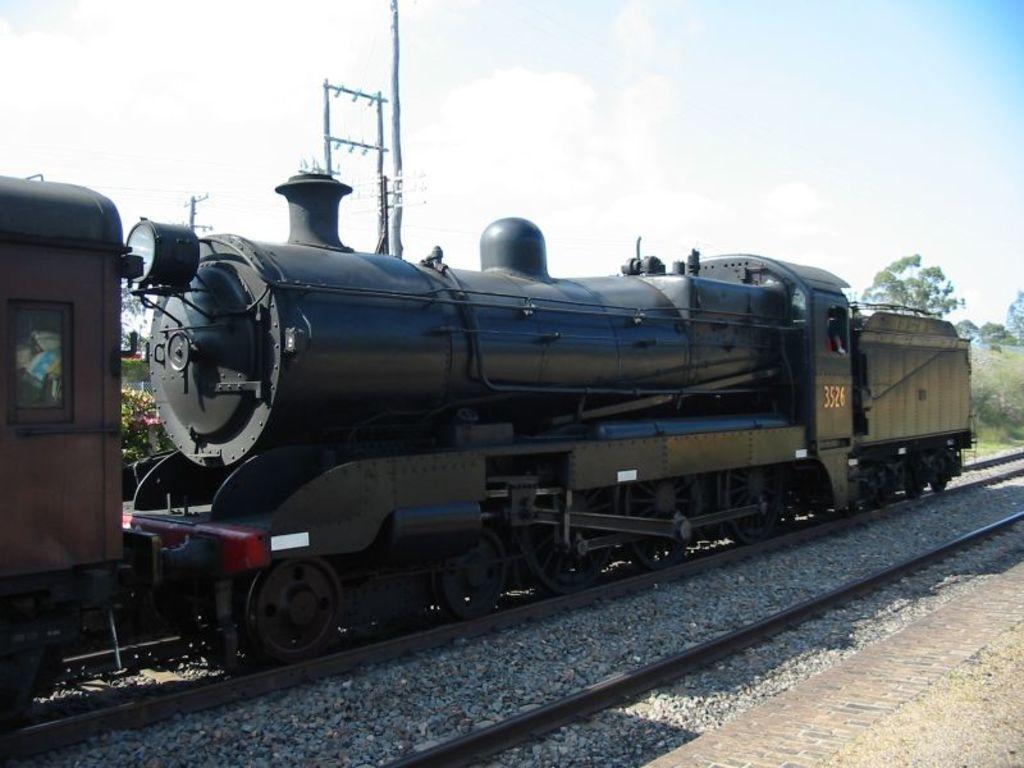Please provide a concise description of this image. This picture might be taken from outside of the and it is sunny. In this image, in the middle, we can see a train moving on the railway track. In the background, we can see some trees and plants, electric pole, electric wires. At the top, we can see a sky, at the bottom, we can see a railway track with some stones and a land. 